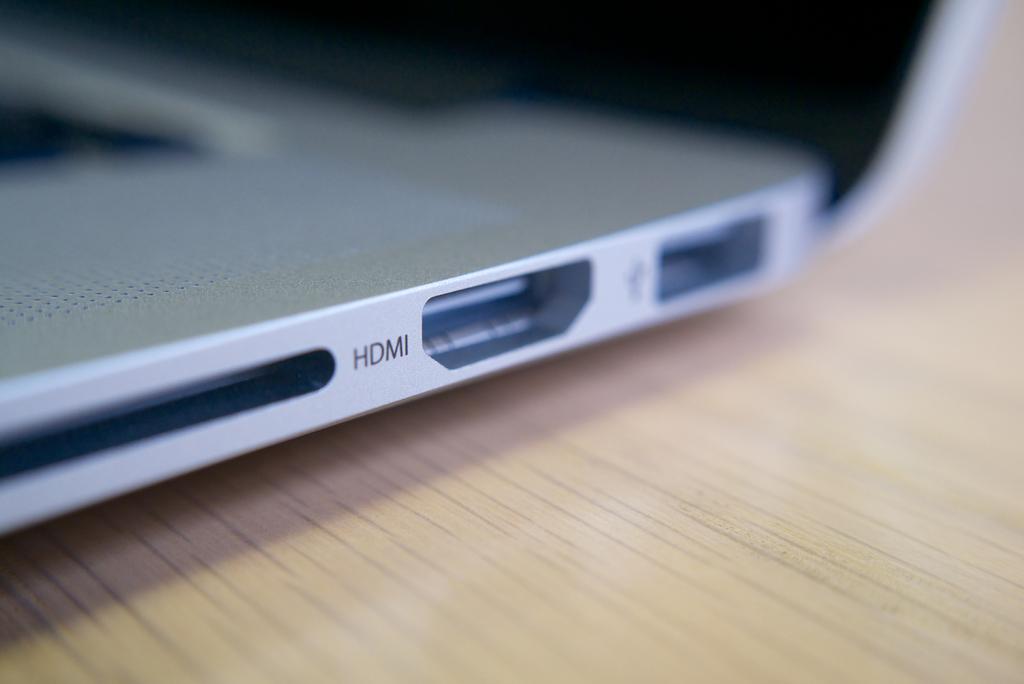What sort of port is that?
Give a very brief answer. Hdmi. 